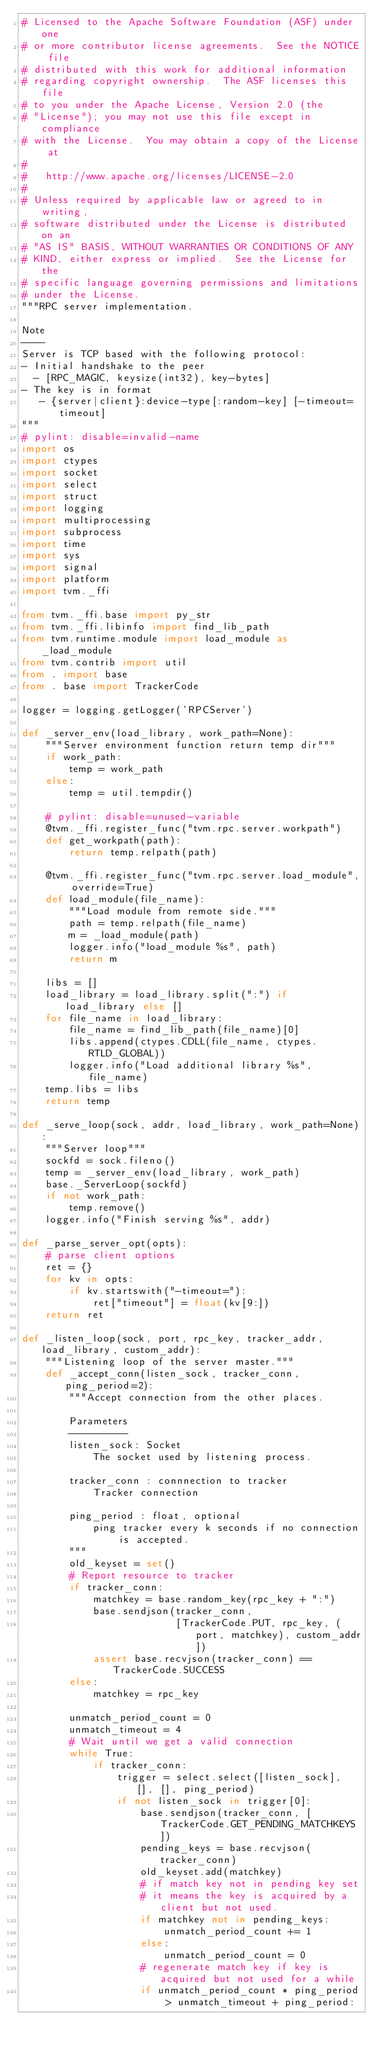Convert code to text. <code><loc_0><loc_0><loc_500><loc_500><_Python_># Licensed to the Apache Software Foundation (ASF) under one
# or more contributor license agreements.  See the NOTICE file
# distributed with this work for additional information
# regarding copyright ownership.  The ASF licenses this file
# to you under the Apache License, Version 2.0 (the
# "License"); you may not use this file except in compliance
# with the License.  You may obtain a copy of the License at
#
#   http://www.apache.org/licenses/LICENSE-2.0
#
# Unless required by applicable law or agreed to in writing,
# software distributed under the License is distributed on an
# "AS IS" BASIS, WITHOUT WARRANTIES OR CONDITIONS OF ANY
# KIND, either express or implied.  See the License for the
# specific language governing permissions and limitations
# under the License.
"""RPC server implementation.

Note
----
Server is TCP based with the following protocol:
- Initial handshake to the peer
  - [RPC_MAGIC, keysize(int32), key-bytes]
- The key is in format
   - {server|client}:device-type[:random-key] [-timeout=timeout]
"""
# pylint: disable=invalid-name
import os
import ctypes
import socket
import select
import struct
import logging
import multiprocessing
import subprocess
import time
import sys
import signal
import platform
import tvm._ffi

from tvm._ffi.base import py_str
from tvm._ffi.libinfo import find_lib_path
from tvm.runtime.module import load_module as _load_module
from tvm.contrib import util
from . import base
from . base import TrackerCode

logger = logging.getLogger('RPCServer')

def _server_env(load_library, work_path=None):
    """Server environment function return temp dir"""
    if work_path:
        temp = work_path
    else:
        temp = util.tempdir()

    # pylint: disable=unused-variable
    @tvm._ffi.register_func("tvm.rpc.server.workpath")
    def get_workpath(path):
        return temp.relpath(path)

    @tvm._ffi.register_func("tvm.rpc.server.load_module", override=True)
    def load_module(file_name):
        """Load module from remote side."""
        path = temp.relpath(file_name)
        m = _load_module(path)
        logger.info("load_module %s", path)
        return m

    libs = []
    load_library = load_library.split(":") if load_library else []
    for file_name in load_library:
        file_name = find_lib_path(file_name)[0]
        libs.append(ctypes.CDLL(file_name, ctypes.RTLD_GLOBAL))
        logger.info("Load additional library %s", file_name)
    temp.libs = libs
    return temp

def _serve_loop(sock, addr, load_library, work_path=None):
    """Server loop"""
    sockfd = sock.fileno()
    temp = _server_env(load_library, work_path)
    base._ServerLoop(sockfd)
    if not work_path:
        temp.remove()
    logger.info("Finish serving %s", addr)

def _parse_server_opt(opts):
    # parse client options
    ret = {}
    for kv in opts:
        if kv.startswith("-timeout="):
            ret["timeout"] = float(kv[9:])
    return ret

def _listen_loop(sock, port, rpc_key, tracker_addr, load_library, custom_addr):
    """Listening loop of the server master."""
    def _accept_conn(listen_sock, tracker_conn, ping_period=2):
        """Accept connection from the other places.

        Parameters
        ----------
        listen_sock: Socket
            The socket used by listening process.

        tracker_conn : connnection to tracker
            Tracker connection

        ping_period : float, optional
            ping tracker every k seconds if no connection is accepted.
        """
        old_keyset = set()
        # Report resource to tracker
        if tracker_conn:
            matchkey = base.random_key(rpc_key + ":")
            base.sendjson(tracker_conn,
                          [TrackerCode.PUT, rpc_key, (port, matchkey), custom_addr])
            assert base.recvjson(tracker_conn) == TrackerCode.SUCCESS
        else:
            matchkey = rpc_key

        unmatch_period_count = 0
        unmatch_timeout = 4
        # Wait until we get a valid connection
        while True:
            if tracker_conn:
                trigger = select.select([listen_sock], [], [], ping_period)
                if not listen_sock in trigger[0]:
                    base.sendjson(tracker_conn, [TrackerCode.GET_PENDING_MATCHKEYS])
                    pending_keys = base.recvjson(tracker_conn)
                    old_keyset.add(matchkey)
                    # if match key not in pending key set
                    # it means the key is acquired by a client but not used.
                    if matchkey not in pending_keys:
                        unmatch_period_count += 1
                    else:
                        unmatch_period_count = 0
                    # regenerate match key if key is acquired but not used for a while
                    if unmatch_period_count * ping_period > unmatch_timeout + ping_period:</code> 